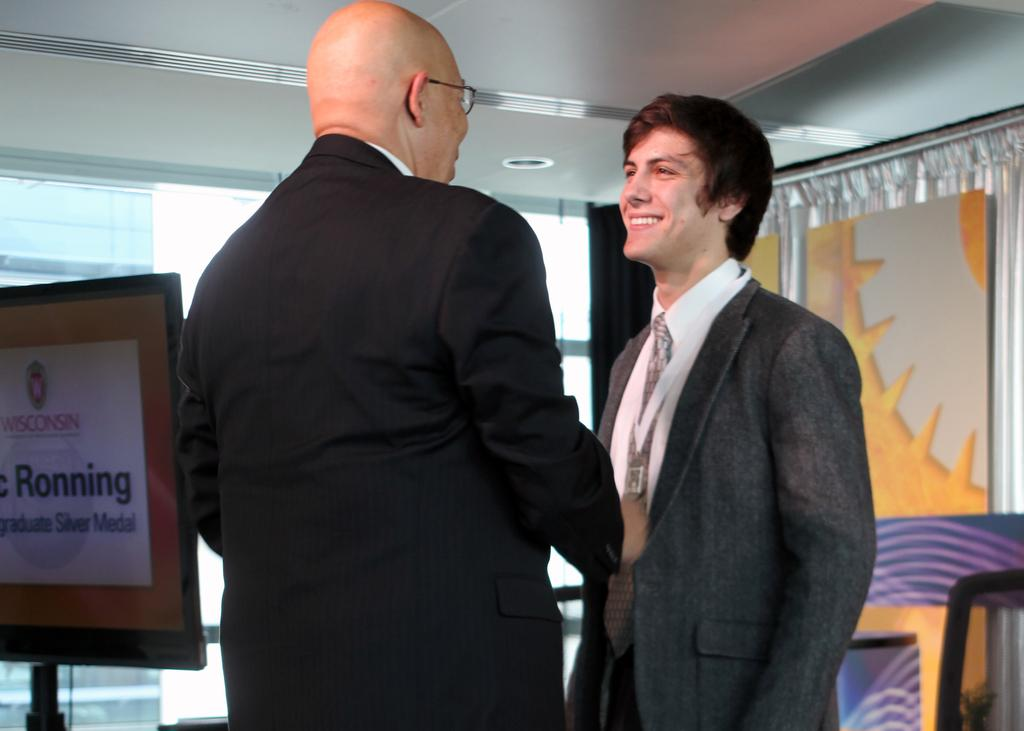What can be seen in the image regarding people? There are men standing in the image. What type of signage is present in the image? There are information boards in the image. What type of lighting is visible in the image? Electric lights are visible in the image. What part of the natural environment is visible in the image? The sky is visible in the image. How many cents are visible on the ground in the image? There is no mention of any currency or coins in the image, so it is not possible to determine the number of cents visible. 